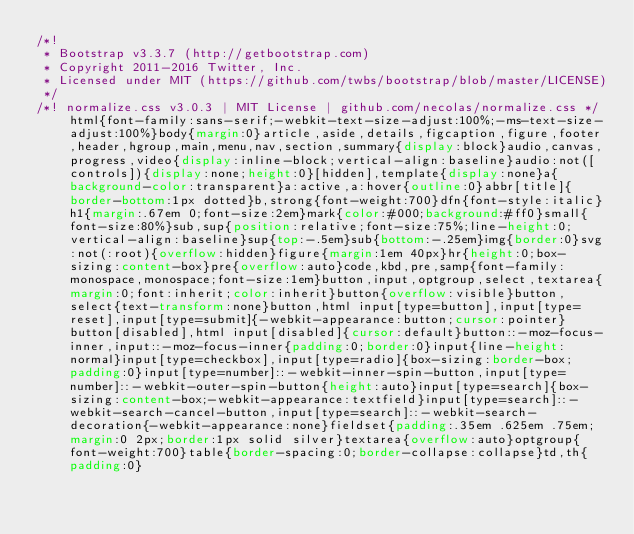<code> <loc_0><loc_0><loc_500><loc_500><_CSS_>/*!
 * Bootstrap v3.3.7 (http://getbootstrap.com)
 * Copyright 2011-2016 Twitter, Inc.
 * Licensed under MIT (https://github.com/twbs/bootstrap/blob/master/LICENSE)
 */
/*! normalize.css v3.0.3 | MIT License | github.com/necolas/normalize.css */html{font-family:sans-serif;-webkit-text-size-adjust:100%;-ms-text-size-adjust:100%}body{margin:0}article,aside,details,figcaption,figure,footer,header,hgroup,main,menu,nav,section,summary{display:block}audio,canvas,progress,video{display:inline-block;vertical-align:baseline}audio:not([controls]){display:none;height:0}[hidden],template{display:none}a{background-color:transparent}a:active,a:hover{outline:0}abbr[title]{border-bottom:1px dotted}b,strong{font-weight:700}dfn{font-style:italic}h1{margin:.67em 0;font-size:2em}mark{color:#000;background:#ff0}small{font-size:80%}sub,sup{position:relative;font-size:75%;line-height:0;vertical-align:baseline}sup{top:-.5em}sub{bottom:-.25em}img{border:0}svg:not(:root){overflow:hidden}figure{margin:1em 40px}hr{height:0;box-sizing:content-box}pre{overflow:auto}code,kbd,pre,samp{font-family:monospace,monospace;font-size:1em}button,input,optgroup,select,textarea{margin:0;font:inherit;color:inherit}button{overflow:visible}button,select{text-transform:none}button,html input[type=button],input[type=reset],input[type=submit]{-webkit-appearance:button;cursor:pointer}button[disabled],html input[disabled]{cursor:default}button::-moz-focus-inner,input::-moz-focus-inner{padding:0;border:0}input{line-height:normal}input[type=checkbox],input[type=radio]{box-sizing:border-box;padding:0}input[type=number]::-webkit-inner-spin-button,input[type=number]::-webkit-outer-spin-button{height:auto}input[type=search]{box-sizing:content-box;-webkit-appearance:textfield}input[type=search]::-webkit-search-cancel-button,input[type=search]::-webkit-search-decoration{-webkit-appearance:none}fieldset{padding:.35em .625em .75em;margin:0 2px;border:1px solid silver}textarea{overflow:auto}optgroup{font-weight:700}table{border-spacing:0;border-collapse:collapse}td,th{padding:0}</code> 